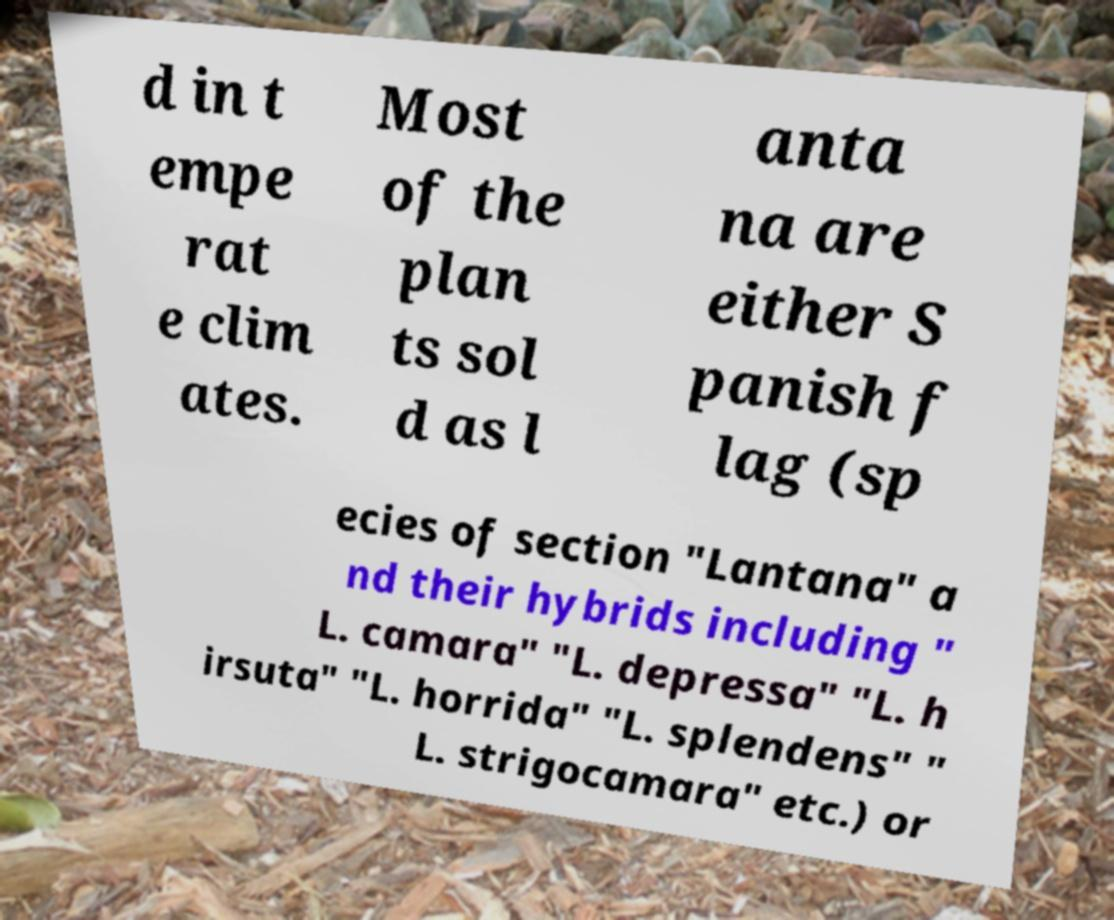Could you assist in decoding the text presented in this image and type it out clearly? d in t empe rat e clim ates. Most of the plan ts sol d as l anta na are either S panish f lag (sp ecies of section "Lantana" a nd their hybrids including " L. camara" "L. depressa" "L. h irsuta" "L. horrida" "L. splendens" " L. strigocamara" etc.) or 